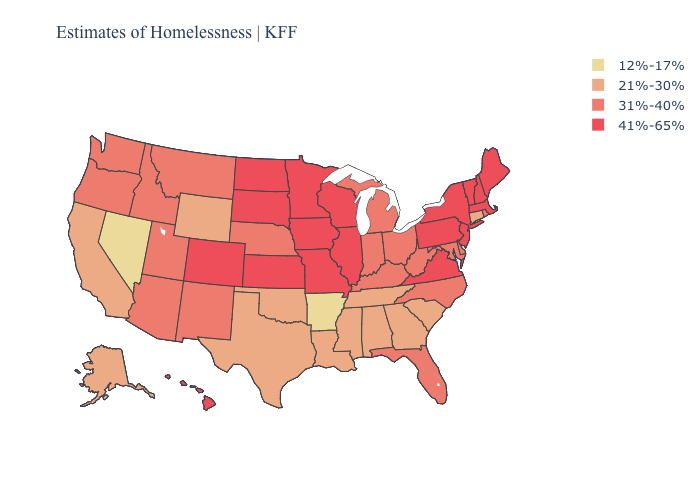Among the states that border Oklahoma , does Arkansas have the lowest value?
Answer briefly. Yes. What is the value of Idaho?
Write a very short answer. 31%-40%. What is the highest value in the Northeast ?
Give a very brief answer. 41%-65%. Among the states that border West Virginia , does Pennsylvania have the highest value?
Be succinct. Yes. Name the states that have a value in the range 41%-65%?
Write a very short answer. Colorado, Hawaii, Illinois, Iowa, Kansas, Maine, Massachusetts, Minnesota, Missouri, New Hampshire, New Jersey, New York, North Dakota, Pennsylvania, South Dakota, Vermont, Virginia, Wisconsin. Does Wisconsin have the lowest value in the MidWest?
Quick response, please. No. What is the lowest value in the USA?
Short answer required. 12%-17%. Does Tennessee have a higher value than Nevada?
Write a very short answer. Yes. Name the states that have a value in the range 12%-17%?
Short answer required. Arkansas, Nevada. Does the first symbol in the legend represent the smallest category?
Be succinct. Yes. Name the states that have a value in the range 41%-65%?
Be succinct. Colorado, Hawaii, Illinois, Iowa, Kansas, Maine, Massachusetts, Minnesota, Missouri, New Hampshire, New Jersey, New York, North Dakota, Pennsylvania, South Dakota, Vermont, Virginia, Wisconsin. Does the map have missing data?
Be succinct. No. What is the value of New Hampshire?
Quick response, please. 41%-65%. Does North Dakota have a higher value than Kentucky?
Be succinct. Yes. What is the value of Alabama?
Write a very short answer. 21%-30%. 